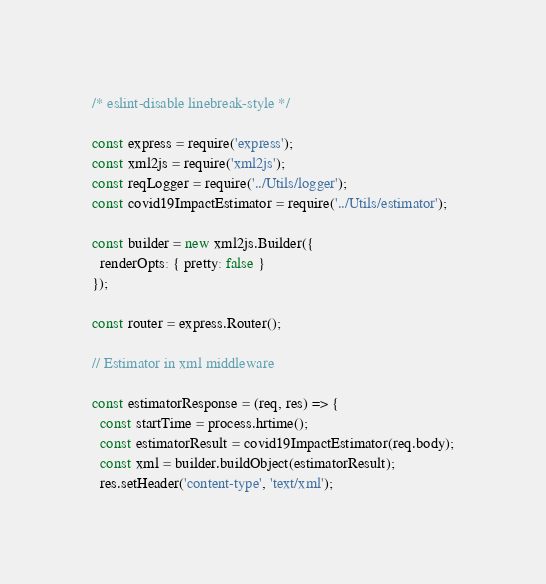Convert code to text. <code><loc_0><loc_0><loc_500><loc_500><_JavaScript_>/* eslint-disable linebreak-style */

const express = require('express');
const xml2js = require('xml2js');
const reqLogger = require('../Utils/logger');
const covid19ImpactEstimator = require('../Utils/estimator');

const builder = new xml2js.Builder({
  renderOpts: { pretty: false }
});

const router = express.Router();

// Estimator in xml middleware

const estimatorResponse = (req, res) => {
  const startTime = process.hrtime();
  const estimatorResult = covid19ImpactEstimator(req.body);
  const xml = builder.buildObject(estimatorResult);
  res.setHeader('content-type', 'text/xml');</code> 